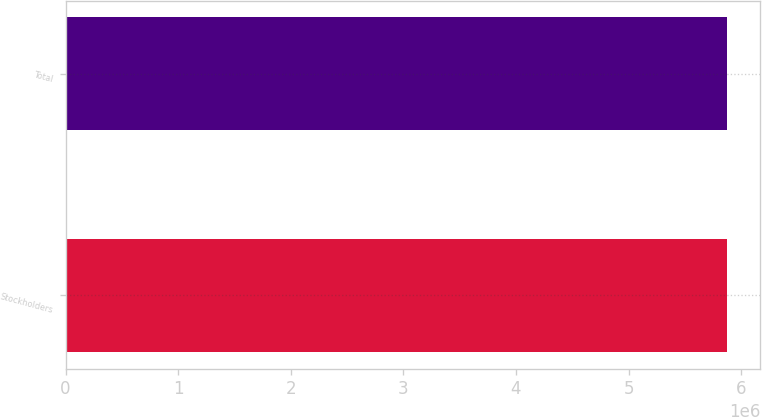Convert chart to OTSL. <chart><loc_0><loc_0><loc_500><loc_500><bar_chart><fcel>Stockholders<fcel>Total<nl><fcel>5.87728e+06<fcel>5.87728e+06<nl></chart> 